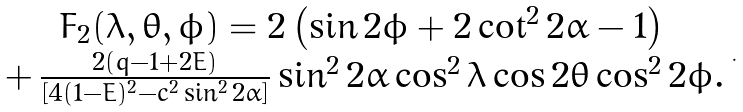<formula> <loc_0><loc_0><loc_500><loc_500>\begin{array} { c } F _ { 2 } ( \lambda , \theta , \phi ) = 2 \left ( \sin 2 \phi + 2 \cot ^ { 2 } 2 \alpha - 1 \right ) \, \\ + \, \frac { 2 \left ( q - 1 + 2 E \right ) } { \left [ 4 ( 1 - E ) ^ { 2 } - c ^ { 2 } \sin ^ { 2 } 2 \alpha \right ] } \sin ^ { 2 } 2 \alpha \cos ^ { 2 } \lambda \cos 2 \theta \cos ^ { 2 } 2 \phi . \end{array} .</formula> 